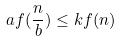Convert formula to latex. <formula><loc_0><loc_0><loc_500><loc_500>a f ( \frac { n } { b } ) \leq k f ( n )</formula> 